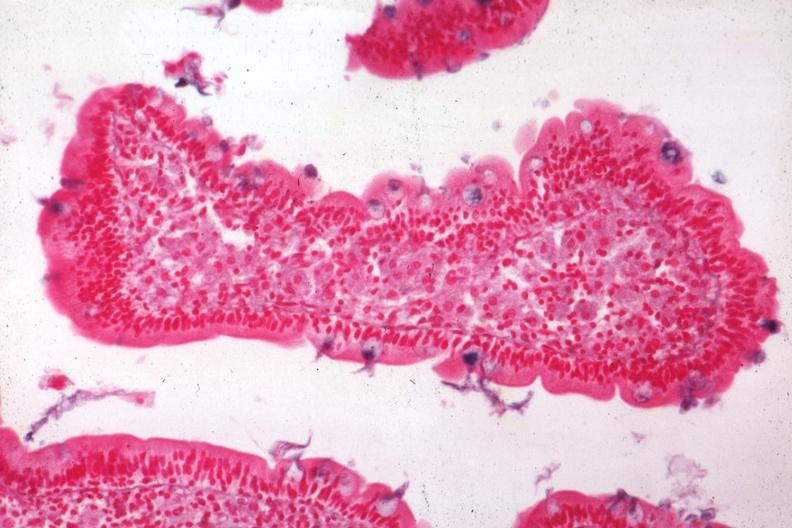what is present?
Answer the question using a single word or phrase. Whipples disease 